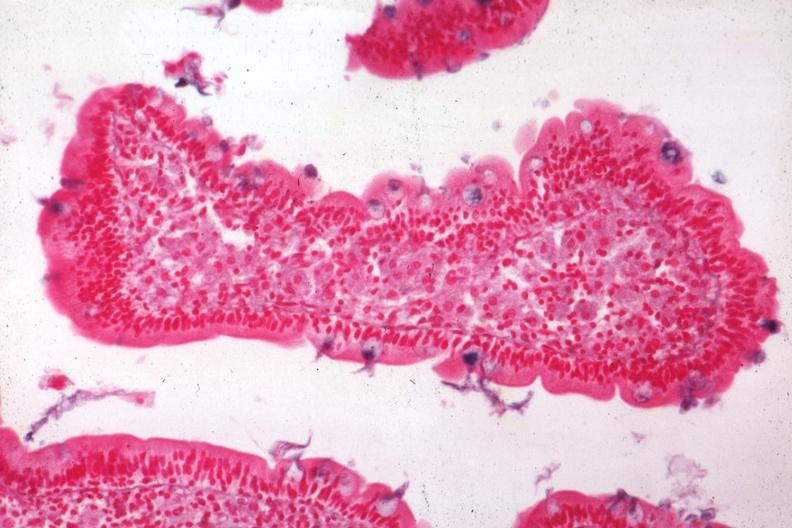what is present?
Answer the question using a single word or phrase. Whipples disease 